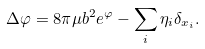Convert formula to latex. <formula><loc_0><loc_0><loc_500><loc_500>\Delta \varphi = 8 \pi \mu b ^ { 2 } e ^ { \varphi } - \sum _ { i } \eta _ { i } \delta _ { x _ { i } } .</formula> 